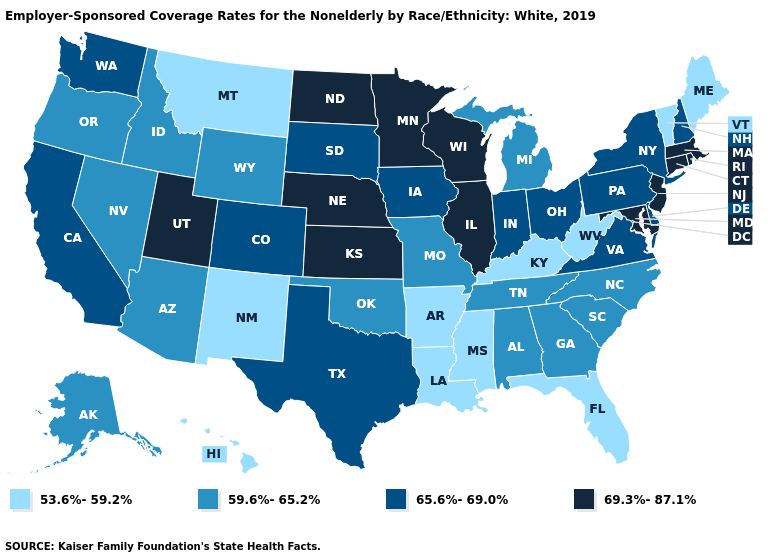Which states hav the highest value in the West?
Keep it brief. Utah. Which states have the lowest value in the USA?
Quick response, please. Arkansas, Florida, Hawaii, Kentucky, Louisiana, Maine, Mississippi, Montana, New Mexico, Vermont, West Virginia. Name the states that have a value in the range 59.6%-65.2%?
Quick response, please. Alabama, Alaska, Arizona, Georgia, Idaho, Michigan, Missouri, Nevada, North Carolina, Oklahoma, Oregon, South Carolina, Tennessee, Wyoming. How many symbols are there in the legend?
Answer briefly. 4. What is the highest value in the USA?
Answer briefly. 69.3%-87.1%. What is the highest value in the West ?
Give a very brief answer. 69.3%-87.1%. Among the states that border Utah , which have the highest value?
Concise answer only. Colorado. Does North Carolina have the highest value in the USA?
Quick response, please. No. Name the states that have a value in the range 69.3%-87.1%?
Be succinct. Connecticut, Illinois, Kansas, Maryland, Massachusetts, Minnesota, Nebraska, New Jersey, North Dakota, Rhode Island, Utah, Wisconsin. Which states hav the highest value in the MidWest?
Answer briefly. Illinois, Kansas, Minnesota, Nebraska, North Dakota, Wisconsin. Does the map have missing data?
Quick response, please. No. Which states have the lowest value in the USA?
Keep it brief. Arkansas, Florida, Hawaii, Kentucky, Louisiana, Maine, Mississippi, Montana, New Mexico, Vermont, West Virginia. What is the value of Michigan?
Write a very short answer. 59.6%-65.2%. Does the map have missing data?
Short answer required. No. Does Missouri have the highest value in the USA?
Give a very brief answer. No. 